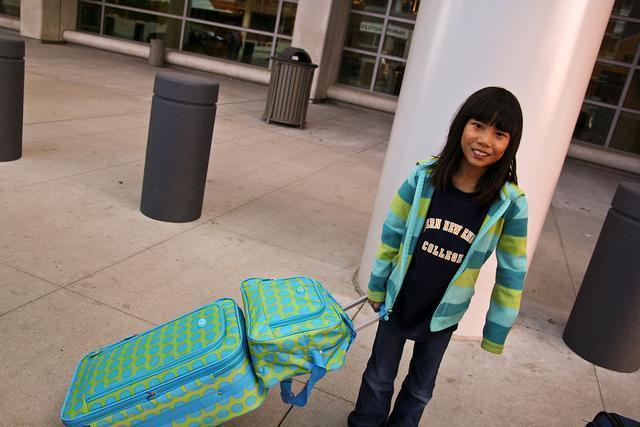Upon which vessel might this person go for a ride soon?
Select the accurate answer and provide explanation: 'Answer: answer
Rationale: rationale.'
Options: Uber, airplane, space ship, steamer. Answer: airplane.
Rationale: She is dragging luggage. luggage is used to go on long trips through the air. 